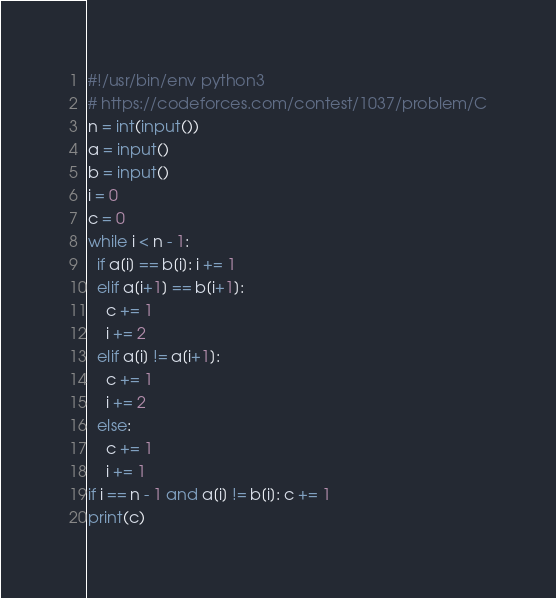<code> <loc_0><loc_0><loc_500><loc_500><_Python_>#!/usr/bin/env python3
# https://codeforces.com/contest/1037/problem/C
n = int(input())
a = input()
b = input()
i = 0
c = 0
while i < n - 1:
  if a[i] == b[i]: i += 1
  elif a[i+1] == b[i+1]:
    c += 1
    i += 2
  elif a[i] != a[i+1]:
    c += 1
    i += 2
  else:
    c += 1
    i += 1
if i == n - 1 and a[i] != b[i]: c += 1
print(c)
</code> 